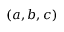Convert formula to latex. <formula><loc_0><loc_0><loc_500><loc_500>( a , b , c )</formula> 